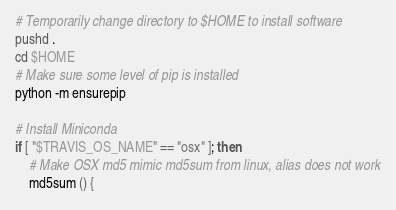<code> <loc_0><loc_0><loc_500><loc_500><_Bash_># Temporarily change directory to $HOME to install software
pushd .
cd $HOME
# Make sure some level of pip is installed
python -m ensurepip

# Install Miniconda
if [ "$TRAVIS_OS_NAME" == "osx" ]; then
    # Make OSX md5 mimic md5sum from linux, alias does not work
    md5sum () {</code> 